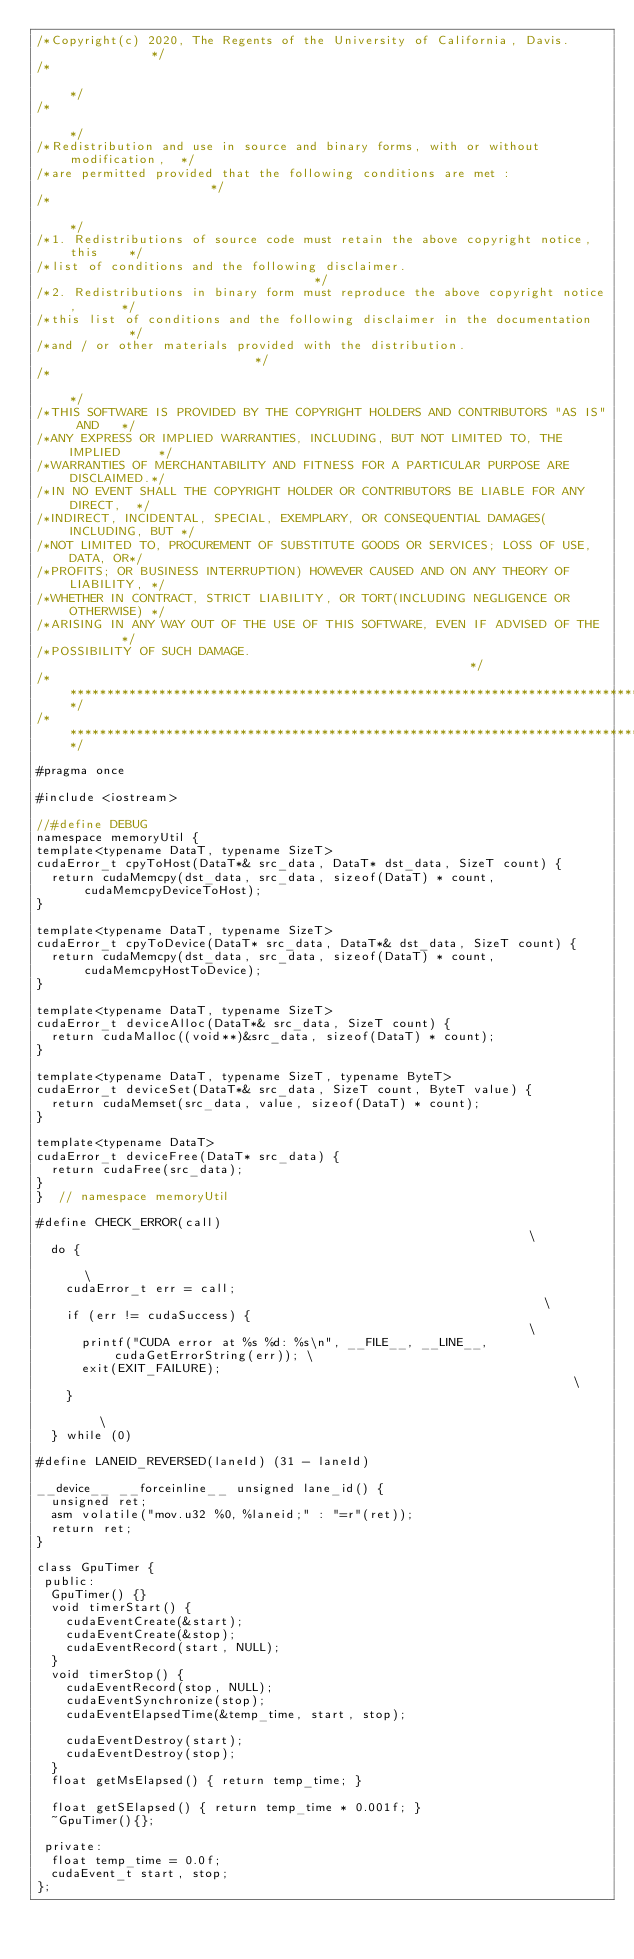Convert code to text. <code><loc_0><loc_0><loc_500><loc_500><_Cuda_>/*Copyright(c) 2020, The Regents of the University of California, Davis.            */
/*                                                                                  */
/*                                                                                  */
/*Redistribution and use in source and binary forms, with or without modification,  */
/*are permitted provided that the following conditions are met :                    */
/*                                                                                  */
/*1. Redistributions of source code must retain the above copyright notice, this    */
/*list of conditions and the following disclaimer.                                  */
/*2. Redistributions in binary form must reproduce the above copyright notice,      */
/*this list of conditions and the following disclaimer in the documentation         */
/*and / or other materials provided with the distribution.                          */
/*                                                                                  */
/*THIS SOFTWARE IS PROVIDED BY THE COPYRIGHT HOLDERS AND CONTRIBUTORS "AS IS" AND   */
/*ANY EXPRESS OR IMPLIED WARRANTIES, INCLUDING, BUT NOT LIMITED TO, THE IMPLIED     */
/*WARRANTIES OF MERCHANTABILITY AND FITNESS FOR A PARTICULAR PURPOSE ARE DISCLAIMED.*/
/*IN NO EVENT SHALL THE COPYRIGHT HOLDER OR CONTRIBUTORS BE LIABLE FOR ANY DIRECT,  */
/*INDIRECT, INCIDENTAL, SPECIAL, EXEMPLARY, OR CONSEQUENTIAL DAMAGES(INCLUDING, BUT */
/*NOT LIMITED TO, PROCUREMENT OF SUBSTITUTE GOODS OR SERVICES; LOSS OF USE, DATA, OR*/
/*PROFITS; OR BUSINESS INTERRUPTION) HOWEVER CAUSED AND ON ANY THEORY OF LIABILITY, */
/*WHETHER IN CONTRACT, STRICT LIABILITY, OR TORT(INCLUDING NEGLIGENCE OR OTHERWISE) */
/*ARISING IN ANY WAY OUT OF THE USE OF THIS SOFTWARE, EVEN IF ADVISED OF THE        */
/*POSSIBILITY OF SUCH DAMAGE.                                                       */
/************************************************************************************/
/************************************************************************************/

#pragma once

#include <iostream>

//#define DEBUG
namespace memoryUtil {
template<typename DataT, typename SizeT>
cudaError_t cpyToHost(DataT*& src_data, DataT* dst_data, SizeT count) {
  return cudaMemcpy(dst_data, src_data, sizeof(DataT) * count, cudaMemcpyDeviceToHost);
}

template<typename DataT, typename SizeT>
cudaError_t cpyToDevice(DataT* src_data, DataT*& dst_data, SizeT count) {
  return cudaMemcpy(dst_data, src_data, sizeof(DataT) * count, cudaMemcpyHostToDevice);
}

template<typename DataT, typename SizeT>
cudaError_t deviceAlloc(DataT*& src_data, SizeT count) {
  return cudaMalloc((void**)&src_data, sizeof(DataT) * count);
}

template<typename DataT, typename SizeT, typename ByteT>
cudaError_t deviceSet(DataT*& src_data, SizeT count, ByteT value) {
  return cudaMemset(src_data, value, sizeof(DataT) * count);
}

template<typename DataT>
cudaError_t deviceFree(DataT* src_data) {
  return cudaFree(src_data);
}
}  // namespace memoryUtil

#define CHECK_ERROR(call)                                                               \
  do {                                                                                  \
    cudaError_t err = call;                                                             \
    if (err != cudaSuccess) {                                                           \
      printf("CUDA error at %s %d: %s\n", __FILE__, __LINE__, cudaGetErrorString(err)); \
      exit(EXIT_FAILURE);                                                               \
    }                                                                                   \
  } while (0)

#define LANEID_REVERSED(laneId) (31 - laneId)

__device__ __forceinline__ unsigned lane_id() {
  unsigned ret;
  asm volatile("mov.u32 %0, %laneid;" : "=r"(ret));
  return ret;
}

class GpuTimer {
 public:
  GpuTimer() {}
  void timerStart() {
    cudaEventCreate(&start);
    cudaEventCreate(&stop);
    cudaEventRecord(start, NULL);
  }
  void timerStop() {
    cudaEventRecord(stop, NULL);
    cudaEventSynchronize(stop);
    cudaEventElapsedTime(&temp_time, start, stop);

    cudaEventDestroy(start);
    cudaEventDestroy(stop);
  }
  float getMsElapsed() { return temp_time; }

  float getSElapsed() { return temp_time * 0.001f; }
  ~GpuTimer(){};

 private:
  float temp_time = 0.0f;
  cudaEvent_t start, stop;
};
</code> 